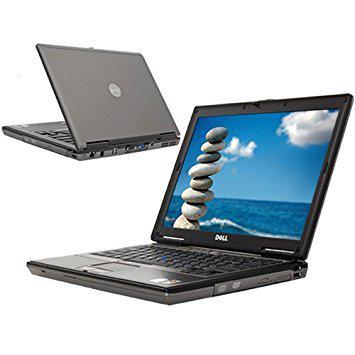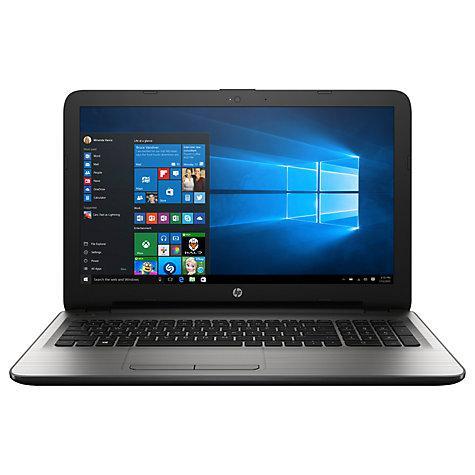The first image is the image on the left, the second image is the image on the right. Assess this claim about the two images: "In one image there is a laptop computer from the brand hp and the other image has a DELL laptop.". Correct or not? Answer yes or no. Yes. The first image is the image on the left, the second image is the image on the right. Evaluate the accuracy of this statement regarding the images: "There is one laptop shown front and back.". Is it true? Answer yes or no. Yes. 